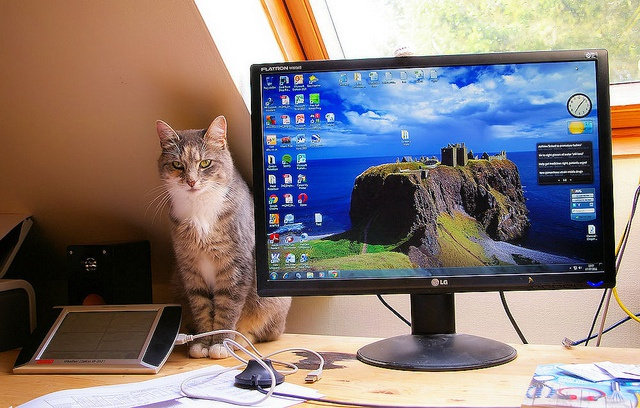Describe the objects in this image and their specific colors. I can see tv in brown, black, lightblue, blue, and gray tones, cat in brown, gray, tan, maroon, and darkgray tones, book in brown, white, lightblue, and darkgray tones, mouse in brown, purple, black, and gray tones, and clock in brown, lightgray, black, darkgray, and lightblue tones in this image. 